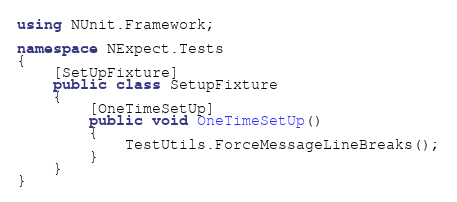Convert code to text. <code><loc_0><loc_0><loc_500><loc_500><_C#_>using NUnit.Framework;

namespace NExpect.Tests
{
    [SetUpFixture]
    public class SetupFixture
    {
        [OneTimeSetUp]
        public void OneTimeSetUp()
        {
            TestUtils.ForceMessageLineBreaks();
        }
    }
}</code> 